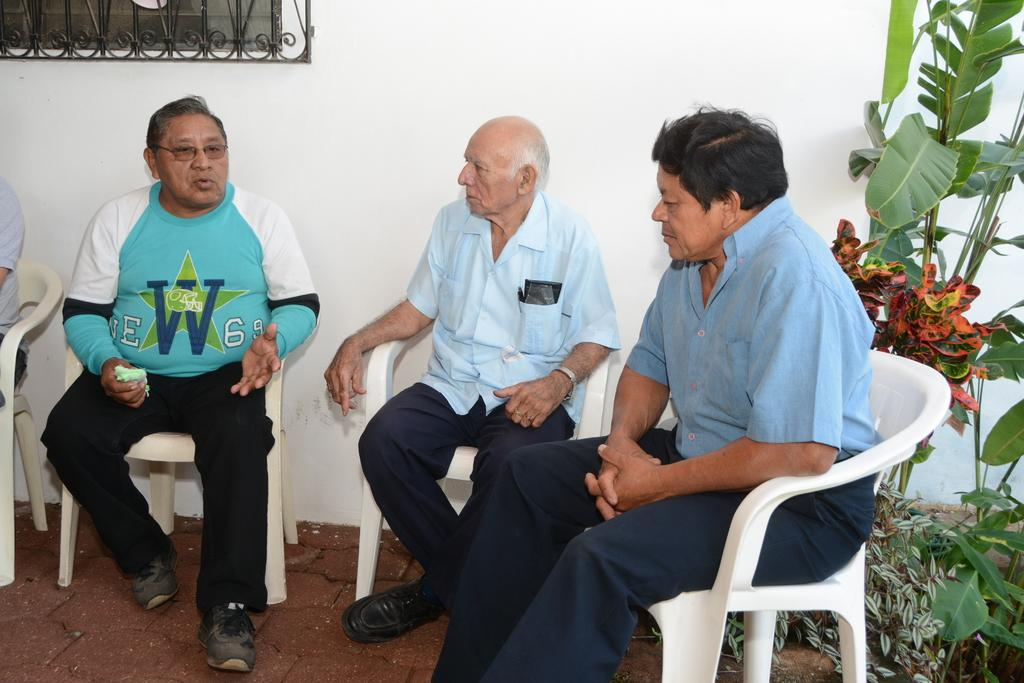How many people are in the image? There are three men in the image. What are the men doing in the image? The men are sitting on a chair. What can be seen on the right side of the image? There is a plant on the right side of the image. What is the color of the wall in the image? There is a white wall in the image. What type of baseball degree does the man on the left have in the image? There is no mention of baseball or degrees in the image; it only shows three men sitting on a chair with a plant on the right side and a white wall in the background. 